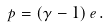Convert formula to latex. <formula><loc_0><loc_0><loc_500><loc_500>p = \left ( \gamma - 1 \right ) e \, .</formula> 